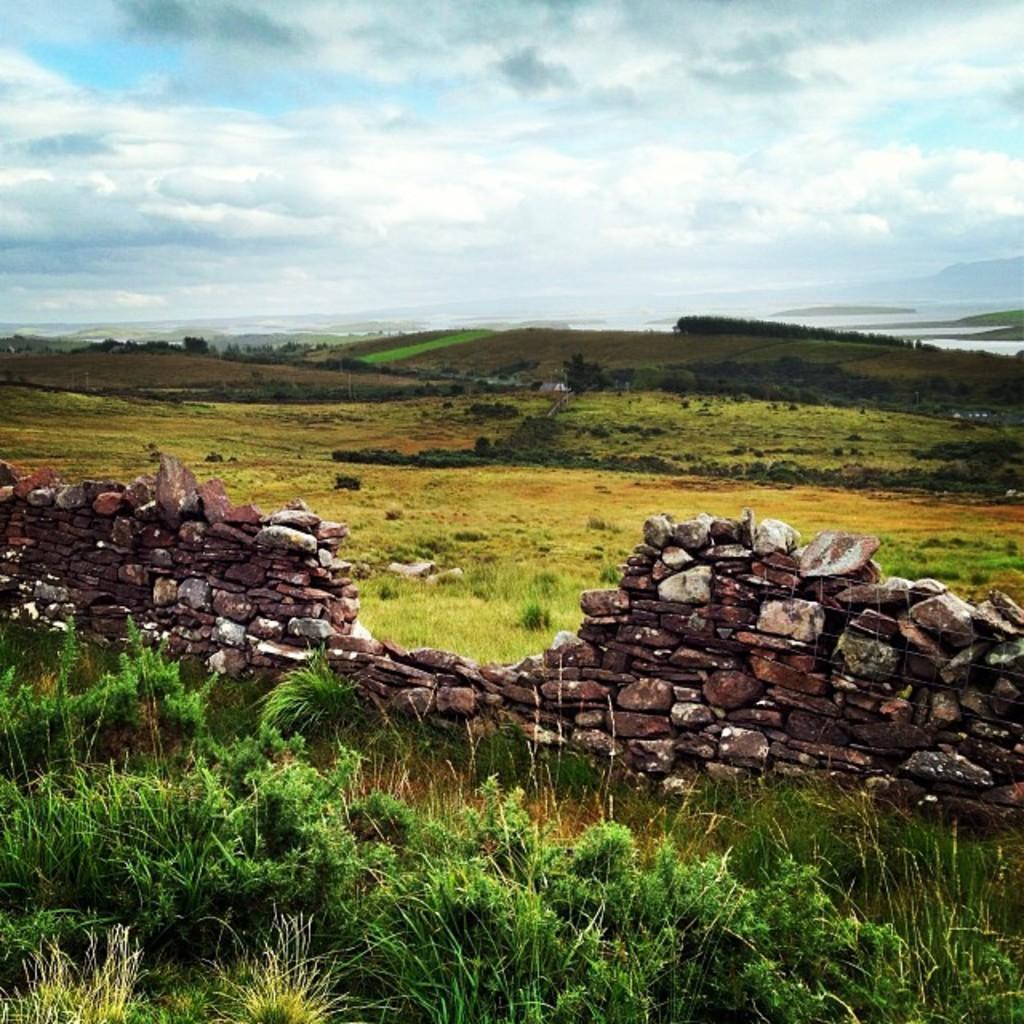How would you summarize this image in a sentence or two? In this picture there is a wall in the foreground. At the back there are plants and there is grass. At the back there are mountains and there is water. At the top there is sky and there are clouds. 